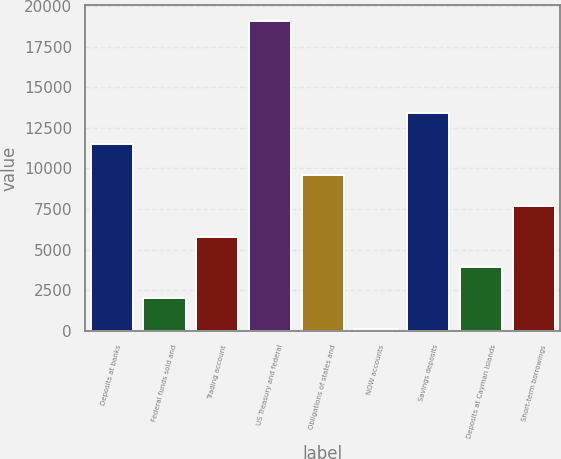Convert chart to OTSL. <chart><loc_0><loc_0><loc_500><loc_500><bar_chart><fcel>Deposits at banks<fcel>Federal funds sold and<fcel>Trading account<fcel>US Treasury and federal<fcel>Obligations of states and<fcel>NOW accounts<fcel>Savings deposits<fcel>Deposits at Cayman Islands<fcel>Short-term borrowings<nl><fcel>11490.8<fcel>2006.8<fcel>5800.4<fcel>19078<fcel>9594<fcel>110<fcel>13387.6<fcel>3903.6<fcel>7697.2<nl></chart> 